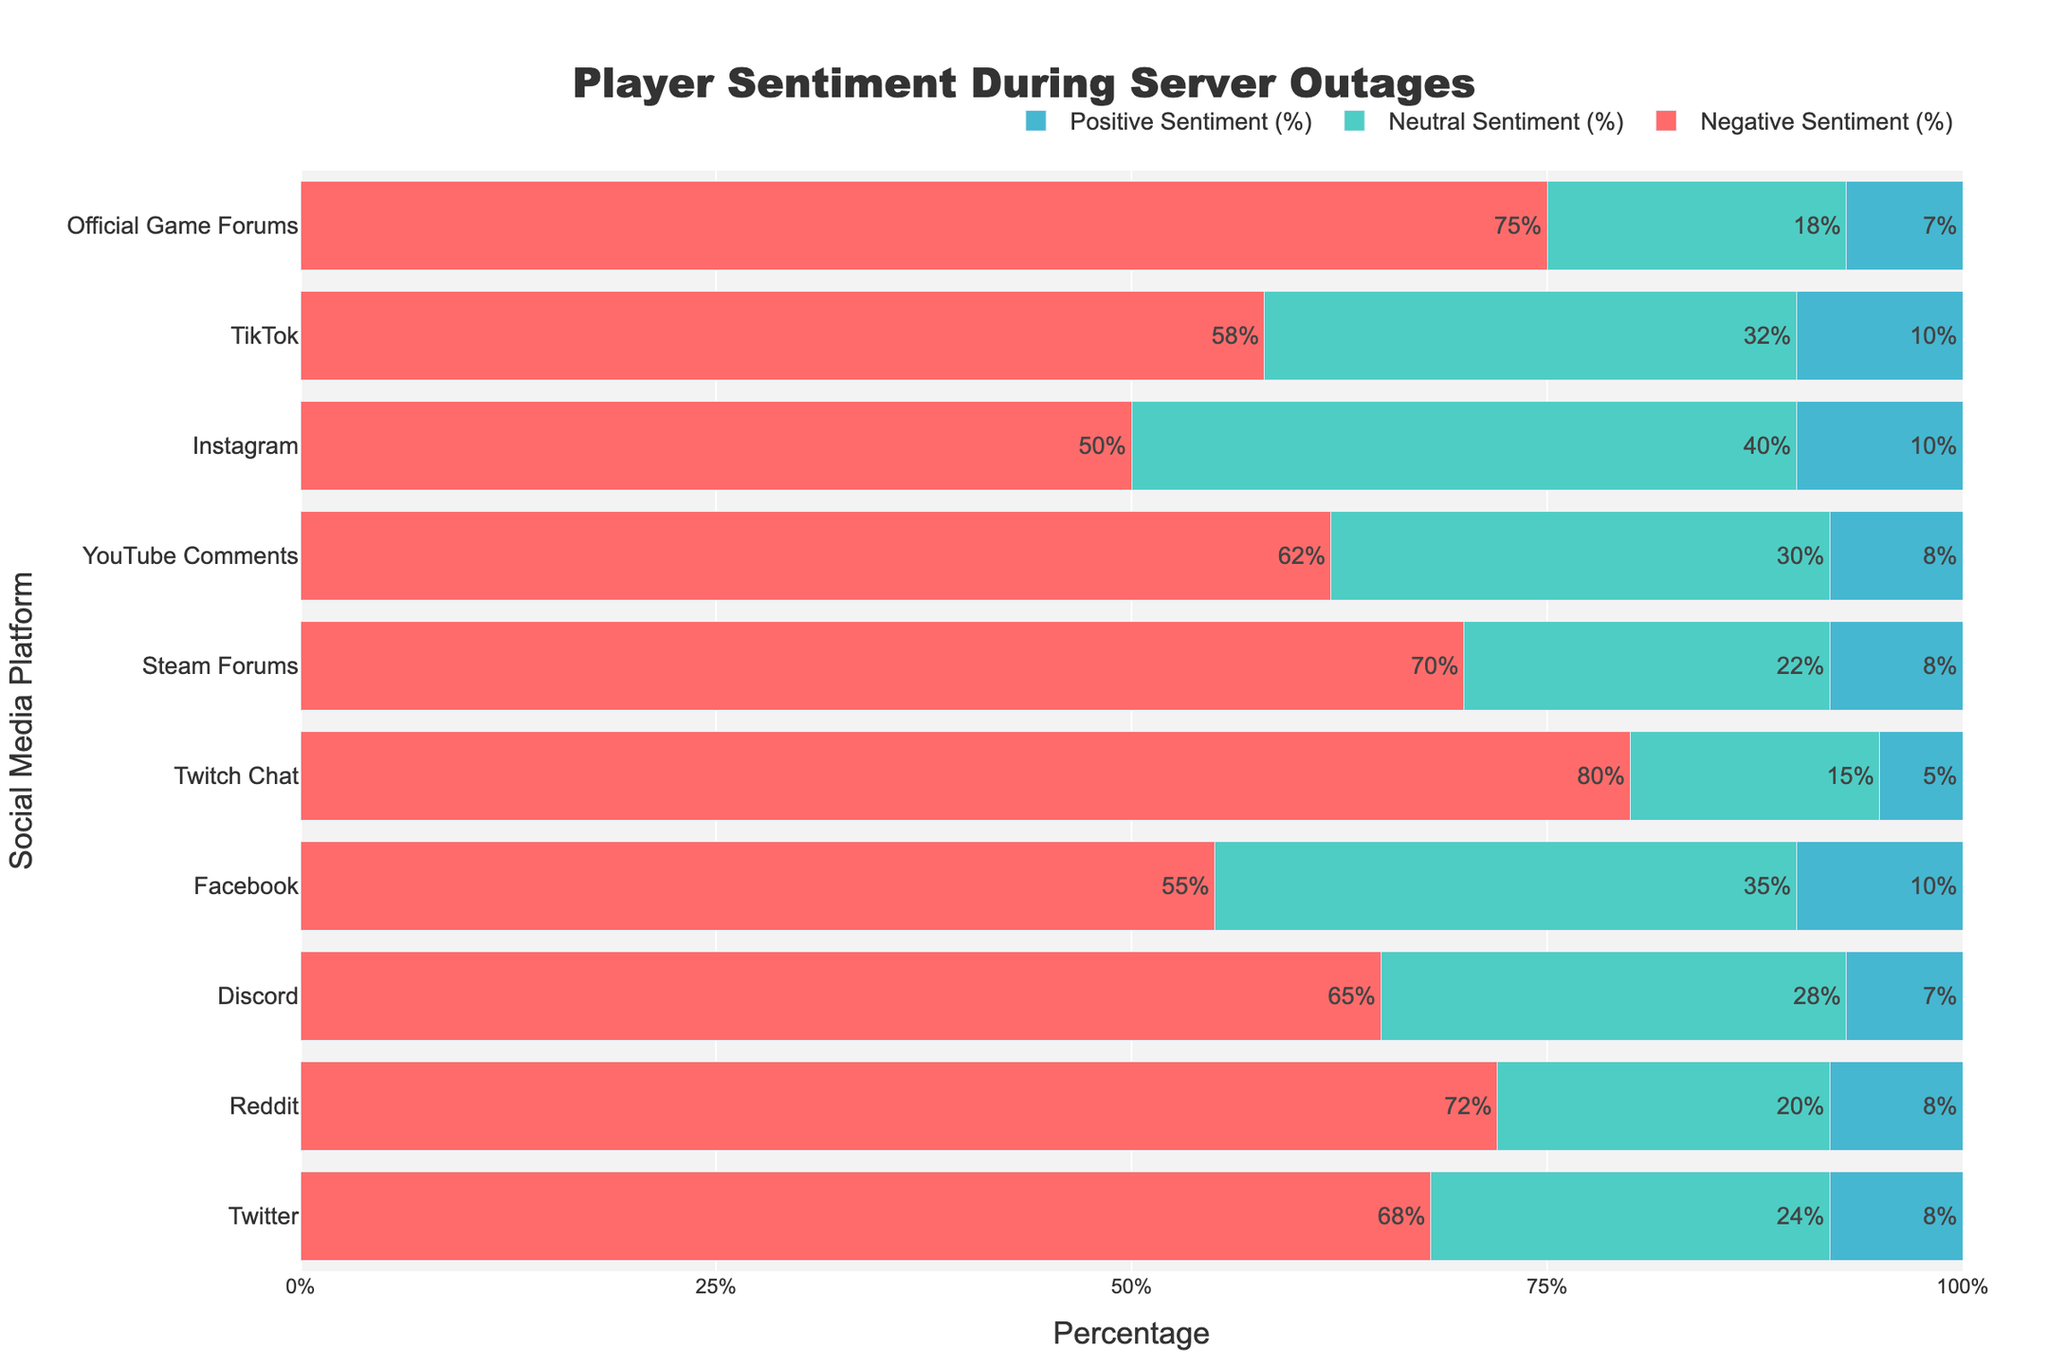Which platform had the highest negative sentiment during server outages? The platform with the highest negative sentiment can be identified by looking at the tallest red bar. The highest red bar corresponds to Twitch Chat at 80%.
Answer: Twitch Chat Which platform had the highest positive sentiment during server outages? The platform with the highest positive sentiment can be identified by looking at the tallest blue bar. Instagram, Facebook, and TikTok have the tallest blue bars, each at 10%.
Answer: Instagram, Facebook, TikTok Compare the neutral sentiment percentages between Facebook and Twitter. Which one was higher? To find which platform had higher neutral sentiment, compare the height of the green bars for Facebook and Twitter. Facebook's green bar (35%) is taller than Twitter's (24%).
Answer: Facebook What is the combined percentage of neutral and positive sentiments on YouTube Comments? Add the green bar (neutral sentiment) and the blue bar (positive sentiment) percentages for YouTube Comments: 30% (neutral) + 8% (positive) = 38%.
Answer: 38% How do the neutral and positive sentiments on TikTok compare to those on Reddit? Which platform has a higher combined percentage? Sum the green (neutral) and blue (positive) bars for both platforms. TikTok: 32% + 10% = 42%. Reddit: 20% + 8% = 28%. TikTok has a higher combined percentage.
Answer: TikTok On which platform is the negative sentiment closest to 60%? By observing the heights of the red bars, TikTok (58%) is the closest to 60%.
Answer: TikTok What is the range of positive sentiment percentages displayed on the chart? The range can be determined by identifying the minimum and maximum positive sentiment values. The minimum is 5% (Twitch Chat), and the maximum is 10% (Instagram, Facebook, TikTok). The range is 10% - 5% = 5%.
Answer: 5% Which platform has the smallest percentage difference between neutral and positive sentiments? Calculate the difference between neutral and positive sentiments for each platform and identify the smallest difference. For Instagram, the difference is 40% - 10% = 30%. This is the smallest difference.
Answer: Instagram Which social media platform has the highest combined neutral and positive sentiment? Add the green (neutral) and blue (positive) bar percentages for each platform: Facebook (35% + 10% = 45%), Instagram (40% + 10% = 50%), and so on. Instagram has the highest combined value of 50%.
Answer: Instagram How does the negative sentiment on Official Game Forums compare to that on Steam Forums? Compare the height of the red bars representing negative sentiment for both platforms. Official Game Forums' red bar (75%) is taller than Steam Forums' (70%).
Answer: Official Game Forums 